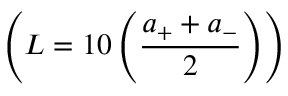Convert formula to latex. <formula><loc_0><loc_0><loc_500><loc_500>\left ( L = 1 0 \left ( \frac { a _ { + } + a _ { - } } { 2 } \right ) \right )</formula> 